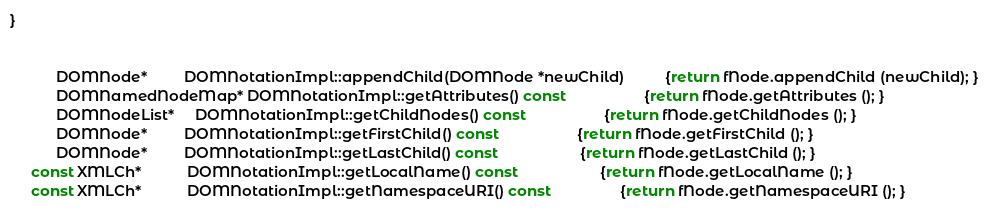<code> <loc_0><loc_0><loc_500><loc_500><_C++_>}


           DOMNode*         DOMNotationImpl::appendChild(DOMNode *newChild)          {return fNode.appendChild (newChild); }
           DOMNamedNodeMap* DOMNotationImpl::getAttributes() const                   {return fNode.getAttributes (); }
           DOMNodeList*     DOMNotationImpl::getChildNodes() const                   {return fNode.getChildNodes (); }
           DOMNode*         DOMNotationImpl::getFirstChild() const                   {return fNode.getFirstChild (); }
           DOMNode*         DOMNotationImpl::getLastChild() const                    {return fNode.getLastChild (); }
     const XMLCh*           DOMNotationImpl::getLocalName() const                    {return fNode.getLocalName (); }
     const XMLCh*           DOMNotationImpl::getNamespaceURI() const                 {return fNode.getNamespaceURI (); }</code> 